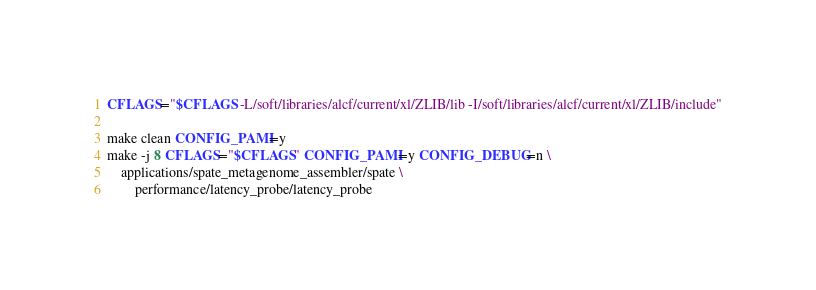Convert code to text. <code><loc_0><loc_0><loc_500><loc_500><_Bash_>CFLAGS="$CFLAGS -L/soft/libraries/alcf/current/xl/ZLIB/lib -I/soft/libraries/alcf/current/xl/ZLIB/include"

make clean CONFIG_PAMI=y
make -j 8 CFLAGS="$CFLAGS" CONFIG_PAMI=y CONFIG_DEBUG=n \
    applications/spate_metagenome_assembler/spate \
        performance/latency_probe/latency_probe

</code> 